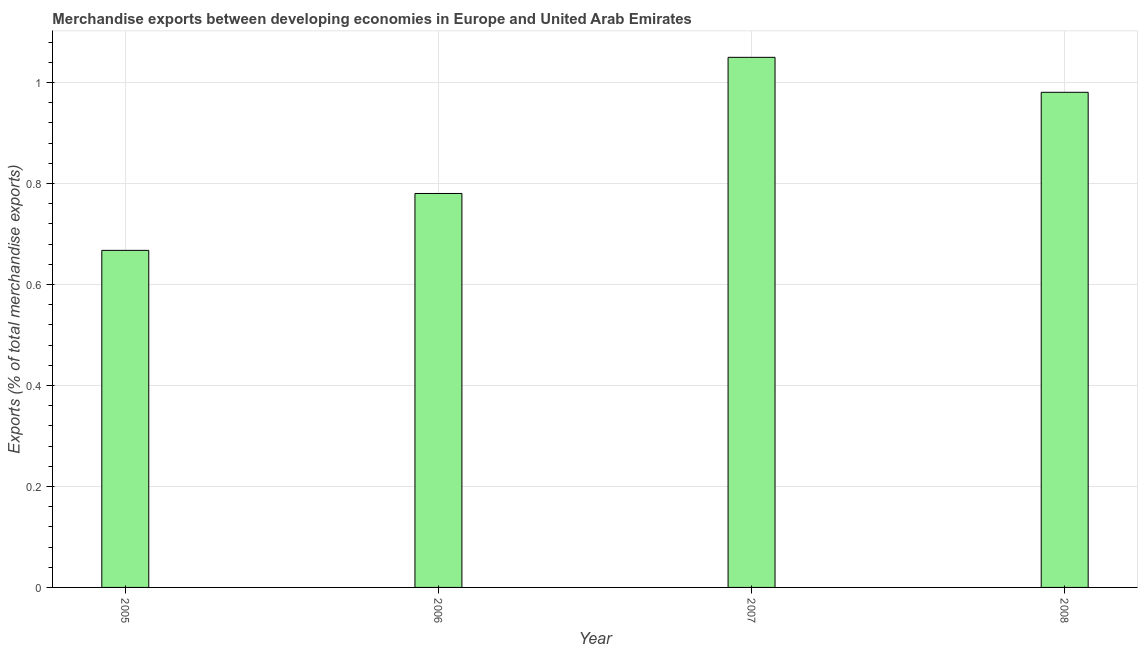What is the title of the graph?
Keep it short and to the point. Merchandise exports between developing economies in Europe and United Arab Emirates. What is the label or title of the Y-axis?
Your answer should be very brief. Exports (% of total merchandise exports). What is the merchandise exports in 2008?
Your response must be concise. 0.98. Across all years, what is the maximum merchandise exports?
Keep it short and to the point. 1.05. Across all years, what is the minimum merchandise exports?
Offer a terse response. 0.67. In which year was the merchandise exports maximum?
Keep it short and to the point. 2007. What is the sum of the merchandise exports?
Your answer should be compact. 3.48. What is the difference between the merchandise exports in 2005 and 2006?
Ensure brevity in your answer.  -0.11. What is the average merchandise exports per year?
Your answer should be very brief. 0.87. What is the median merchandise exports?
Your answer should be compact. 0.88. In how many years, is the merchandise exports greater than 0.24 %?
Provide a succinct answer. 4. Do a majority of the years between 2008 and 2007 (inclusive) have merchandise exports greater than 0.04 %?
Offer a terse response. No. What is the ratio of the merchandise exports in 2006 to that in 2007?
Offer a terse response. 0.74. What is the difference between the highest and the second highest merchandise exports?
Offer a very short reply. 0.07. Is the sum of the merchandise exports in 2006 and 2007 greater than the maximum merchandise exports across all years?
Your response must be concise. Yes. What is the difference between the highest and the lowest merchandise exports?
Give a very brief answer. 0.38. In how many years, is the merchandise exports greater than the average merchandise exports taken over all years?
Your response must be concise. 2. What is the difference between two consecutive major ticks on the Y-axis?
Ensure brevity in your answer.  0.2. What is the Exports (% of total merchandise exports) of 2005?
Your answer should be very brief. 0.67. What is the Exports (% of total merchandise exports) in 2006?
Your response must be concise. 0.78. What is the Exports (% of total merchandise exports) in 2007?
Make the answer very short. 1.05. What is the Exports (% of total merchandise exports) of 2008?
Offer a terse response. 0.98. What is the difference between the Exports (% of total merchandise exports) in 2005 and 2006?
Your answer should be very brief. -0.11. What is the difference between the Exports (% of total merchandise exports) in 2005 and 2007?
Your answer should be very brief. -0.38. What is the difference between the Exports (% of total merchandise exports) in 2005 and 2008?
Ensure brevity in your answer.  -0.31. What is the difference between the Exports (% of total merchandise exports) in 2006 and 2007?
Provide a short and direct response. -0.27. What is the difference between the Exports (% of total merchandise exports) in 2006 and 2008?
Your answer should be very brief. -0.2. What is the difference between the Exports (% of total merchandise exports) in 2007 and 2008?
Give a very brief answer. 0.07. What is the ratio of the Exports (% of total merchandise exports) in 2005 to that in 2006?
Keep it short and to the point. 0.86. What is the ratio of the Exports (% of total merchandise exports) in 2005 to that in 2007?
Provide a short and direct response. 0.64. What is the ratio of the Exports (% of total merchandise exports) in 2005 to that in 2008?
Offer a terse response. 0.68. What is the ratio of the Exports (% of total merchandise exports) in 2006 to that in 2007?
Ensure brevity in your answer.  0.74. What is the ratio of the Exports (% of total merchandise exports) in 2006 to that in 2008?
Offer a very short reply. 0.8. What is the ratio of the Exports (% of total merchandise exports) in 2007 to that in 2008?
Your answer should be compact. 1.07. 